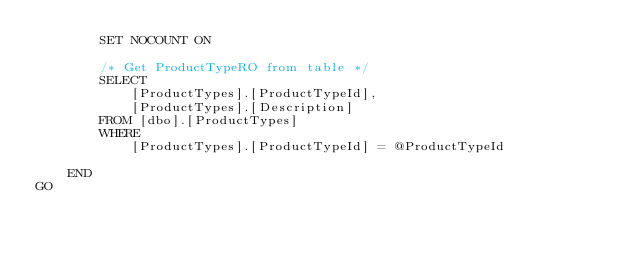Convert code to text. <code><loc_0><loc_0><loc_500><loc_500><_SQL_>        SET NOCOUNT ON

        /* Get ProductTypeRO from table */
        SELECT
            [ProductTypes].[ProductTypeId],
            [ProductTypes].[Description]
        FROM [dbo].[ProductTypes]
        WHERE
            [ProductTypes].[ProductTypeId] = @ProductTypeId

    END
GO

</code> 